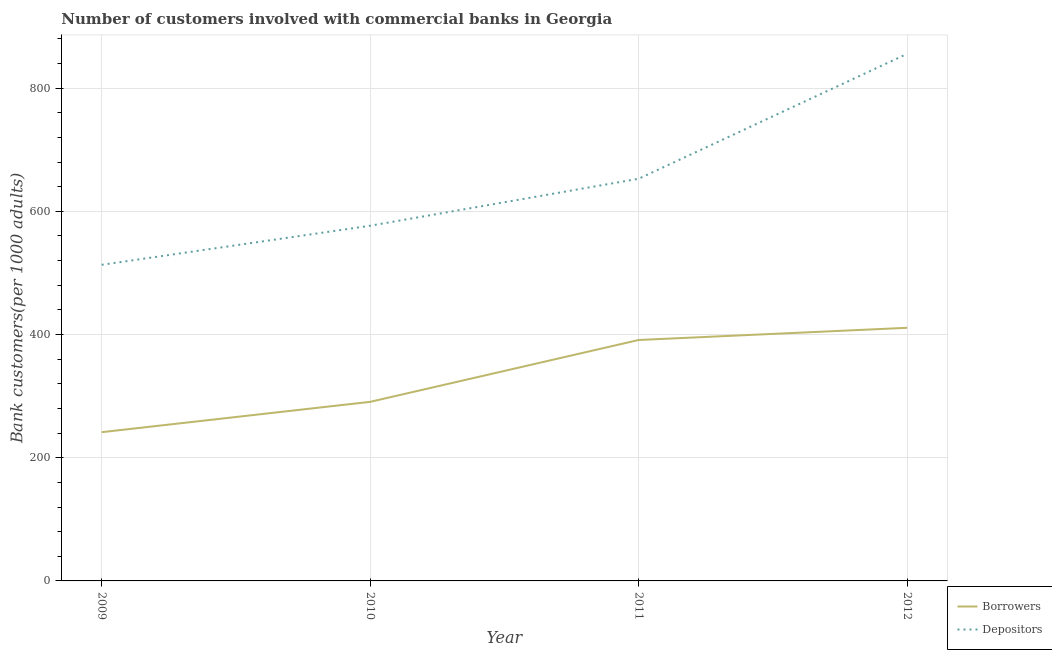How many different coloured lines are there?
Provide a succinct answer. 2. Is the number of lines equal to the number of legend labels?
Your answer should be very brief. Yes. What is the number of depositors in 2012?
Your answer should be very brief. 855.71. Across all years, what is the maximum number of borrowers?
Provide a succinct answer. 410.92. Across all years, what is the minimum number of depositors?
Your answer should be very brief. 513.17. In which year was the number of borrowers maximum?
Offer a very short reply. 2012. In which year was the number of depositors minimum?
Your response must be concise. 2009. What is the total number of depositors in the graph?
Make the answer very short. 2598.37. What is the difference between the number of depositors in 2009 and that in 2010?
Your response must be concise. -63.44. What is the difference between the number of depositors in 2012 and the number of borrowers in 2010?
Your answer should be very brief. 564.99. What is the average number of depositors per year?
Provide a succinct answer. 649.59. In the year 2011, what is the difference between the number of depositors and number of borrowers?
Your answer should be compact. 261.76. What is the ratio of the number of depositors in 2009 to that in 2011?
Provide a succinct answer. 0.79. Is the number of depositors in 2010 less than that in 2011?
Your answer should be very brief. Yes. What is the difference between the highest and the second highest number of borrowers?
Ensure brevity in your answer.  19.79. What is the difference between the highest and the lowest number of depositors?
Your answer should be very brief. 342.55. Does the number of borrowers monotonically increase over the years?
Make the answer very short. Yes. Is the number of borrowers strictly less than the number of depositors over the years?
Your answer should be very brief. Yes. How many years are there in the graph?
Provide a short and direct response. 4. What is the difference between two consecutive major ticks on the Y-axis?
Your response must be concise. 200. Are the values on the major ticks of Y-axis written in scientific E-notation?
Your response must be concise. No. Does the graph contain any zero values?
Your answer should be compact. No. Where does the legend appear in the graph?
Offer a terse response. Bottom right. How are the legend labels stacked?
Offer a terse response. Vertical. What is the title of the graph?
Your answer should be compact. Number of customers involved with commercial banks in Georgia. Does "% of GNI" appear as one of the legend labels in the graph?
Keep it short and to the point. No. What is the label or title of the X-axis?
Provide a succinct answer. Year. What is the label or title of the Y-axis?
Keep it short and to the point. Bank customers(per 1000 adults). What is the Bank customers(per 1000 adults) in Borrowers in 2009?
Ensure brevity in your answer.  241.45. What is the Bank customers(per 1000 adults) in Depositors in 2009?
Make the answer very short. 513.17. What is the Bank customers(per 1000 adults) of Borrowers in 2010?
Make the answer very short. 290.72. What is the Bank customers(per 1000 adults) in Depositors in 2010?
Your response must be concise. 576.61. What is the Bank customers(per 1000 adults) in Borrowers in 2011?
Make the answer very short. 391.13. What is the Bank customers(per 1000 adults) of Depositors in 2011?
Offer a very short reply. 652.89. What is the Bank customers(per 1000 adults) of Borrowers in 2012?
Your response must be concise. 410.92. What is the Bank customers(per 1000 adults) in Depositors in 2012?
Your answer should be compact. 855.71. Across all years, what is the maximum Bank customers(per 1000 adults) of Borrowers?
Provide a succinct answer. 410.92. Across all years, what is the maximum Bank customers(per 1000 adults) in Depositors?
Make the answer very short. 855.71. Across all years, what is the minimum Bank customers(per 1000 adults) of Borrowers?
Ensure brevity in your answer.  241.45. Across all years, what is the minimum Bank customers(per 1000 adults) of Depositors?
Ensure brevity in your answer.  513.17. What is the total Bank customers(per 1000 adults) in Borrowers in the graph?
Make the answer very short. 1334.22. What is the total Bank customers(per 1000 adults) of Depositors in the graph?
Provide a succinct answer. 2598.37. What is the difference between the Bank customers(per 1000 adults) of Borrowers in 2009 and that in 2010?
Your response must be concise. -49.27. What is the difference between the Bank customers(per 1000 adults) of Depositors in 2009 and that in 2010?
Ensure brevity in your answer.  -63.44. What is the difference between the Bank customers(per 1000 adults) in Borrowers in 2009 and that in 2011?
Offer a very short reply. -149.68. What is the difference between the Bank customers(per 1000 adults) of Depositors in 2009 and that in 2011?
Provide a short and direct response. -139.72. What is the difference between the Bank customers(per 1000 adults) in Borrowers in 2009 and that in 2012?
Make the answer very short. -169.47. What is the difference between the Bank customers(per 1000 adults) in Depositors in 2009 and that in 2012?
Offer a terse response. -342.55. What is the difference between the Bank customers(per 1000 adults) in Borrowers in 2010 and that in 2011?
Your response must be concise. -100.4. What is the difference between the Bank customers(per 1000 adults) of Depositors in 2010 and that in 2011?
Keep it short and to the point. -76.28. What is the difference between the Bank customers(per 1000 adults) of Borrowers in 2010 and that in 2012?
Your answer should be compact. -120.2. What is the difference between the Bank customers(per 1000 adults) in Depositors in 2010 and that in 2012?
Offer a very short reply. -279.11. What is the difference between the Bank customers(per 1000 adults) in Borrowers in 2011 and that in 2012?
Provide a short and direct response. -19.79. What is the difference between the Bank customers(per 1000 adults) of Depositors in 2011 and that in 2012?
Ensure brevity in your answer.  -202.83. What is the difference between the Bank customers(per 1000 adults) in Borrowers in 2009 and the Bank customers(per 1000 adults) in Depositors in 2010?
Keep it short and to the point. -335.16. What is the difference between the Bank customers(per 1000 adults) of Borrowers in 2009 and the Bank customers(per 1000 adults) of Depositors in 2011?
Your answer should be compact. -411.43. What is the difference between the Bank customers(per 1000 adults) of Borrowers in 2009 and the Bank customers(per 1000 adults) of Depositors in 2012?
Give a very brief answer. -614.26. What is the difference between the Bank customers(per 1000 adults) of Borrowers in 2010 and the Bank customers(per 1000 adults) of Depositors in 2011?
Provide a short and direct response. -362.16. What is the difference between the Bank customers(per 1000 adults) in Borrowers in 2010 and the Bank customers(per 1000 adults) in Depositors in 2012?
Your answer should be compact. -564.99. What is the difference between the Bank customers(per 1000 adults) of Borrowers in 2011 and the Bank customers(per 1000 adults) of Depositors in 2012?
Your answer should be very brief. -464.59. What is the average Bank customers(per 1000 adults) in Borrowers per year?
Provide a succinct answer. 333.56. What is the average Bank customers(per 1000 adults) of Depositors per year?
Offer a very short reply. 649.59. In the year 2009, what is the difference between the Bank customers(per 1000 adults) in Borrowers and Bank customers(per 1000 adults) in Depositors?
Keep it short and to the point. -271.71. In the year 2010, what is the difference between the Bank customers(per 1000 adults) in Borrowers and Bank customers(per 1000 adults) in Depositors?
Your answer should be very brief. -285.89. In the year 2011, what is the difference between the Bank customers(per 1000 adults) of Borrowers and Bank customers(per 1000 adults) of Depositors?
Provide a short and direct response. -261.76. In the year 2012, what is the difference between the Bank customers(per 1000 adults) of Borrowers and Bank customers(per 1000 adults) of Depositors?
Provide a short and direct response. -444.79. What is the ratio of the Bank customers(per 1000 adults) of Borrowers in 2009 to that in 2010?
Your answer should be very brief. 0.83. What is the ratio of the Bank customers(per 1000 adults) of Depositors in 2009 to that in 2010?
Provide a short and direct response. 0.89. What is the ratio of the Bank customers(per 1000 adults) in Borrowers in 2009 to that in 2011?
Your answer should be very brief. 0.62. What is the ratio of the Bank customers(per 1000 adults) of Depositors in 2009 to that in 2011?
Your answer should be very brief. 0.79. What is the ratio of the Bank customers(per 1000 adults) in Borrowers in 2009 to that in 2012?
Your answer should be very brief. 0.59. What is the ratio of the Bank customers(per 1000 adults) in Depositors in 2009 to that in 2012?
Your answer should be compact. 0.6. What is the ratio of the Bank customers(per 1000 adults) of Borrowers in 2010 to that in 2011?
Ensure brevity in your answer.  0.74. What is the ratio of the Bank customers(per 1000 adults) of Depositors in 2010 to that in 2011?
Provide a short and direct response. 0.88. What is the ratio of the Bank customers(per 1000 adults) of Borrowers in 2010 to that in 2012?
Give a very brief answer. 0.71. What is the ratio of the Bank customers(per 1000 adults) of Depositors in 2010 to that in 2012?
Offer a terse response. 0.67. What is the ratio of the Bank customers(per 1000 adults) in Borrowers in 2011 to that in 2012?
Give a very brief answer. 0.95. What is the ratio of the Bank customers(per 1000 adults) in Depositors in 2011 to that in 2012?
Offer a terse response. 0.76. What is the difference between the highest and the second highest Bank customers(per 1000 adults) in Borrowers?
Make the answer very short. 19.79. What is the difference between the highest and the second highest Bank customers(per 1000 adults) of Depositors?
Give a very brief answer. 202.83. What is the difference between the highest and the lowest Bank customers(per 1000 adults) in Borrowers?
Your answer should be very brief. 169.47. What is the difference between the highest and the lowest Bank customers(per 1000 adults) in Depositors?
Offer a very short reply. 342.55. 